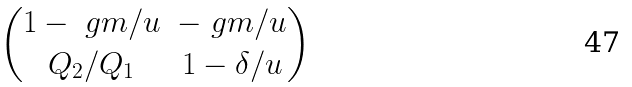<formula> <loc_0><loc_0><loc_500><loc_500>\begin{pmatrix} 1 - \ g m / u & - \ g m / u \\ Q _ { 2 } / Q _ { 1 } & 1 - \delta / u \end{pmatrix}</formula> 